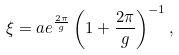Convert formula to latex. <formula><loc_0><loc_0><loc_500><loc_500>\xi = a e ^ { \frac { 2 \pi } { g } } \left ( 1 + \frac { 2 \pi } { g } \right ) ^ { - 1 } ,</formula> 